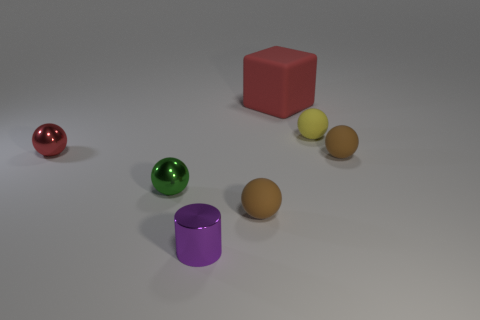There is a shiny ball in front of the red metal thing that is in front of the tiny yellow sphere; is there a big red object that is to the left of it? After carefully examining the image, it appears that there is no large red object situated to the left of the red metal thing, which you referred to. To the left is a purple cylindrical object. It's understandable that the angle and perspective might make it tricky to ascertain the spatial relationships of the objects in question. 